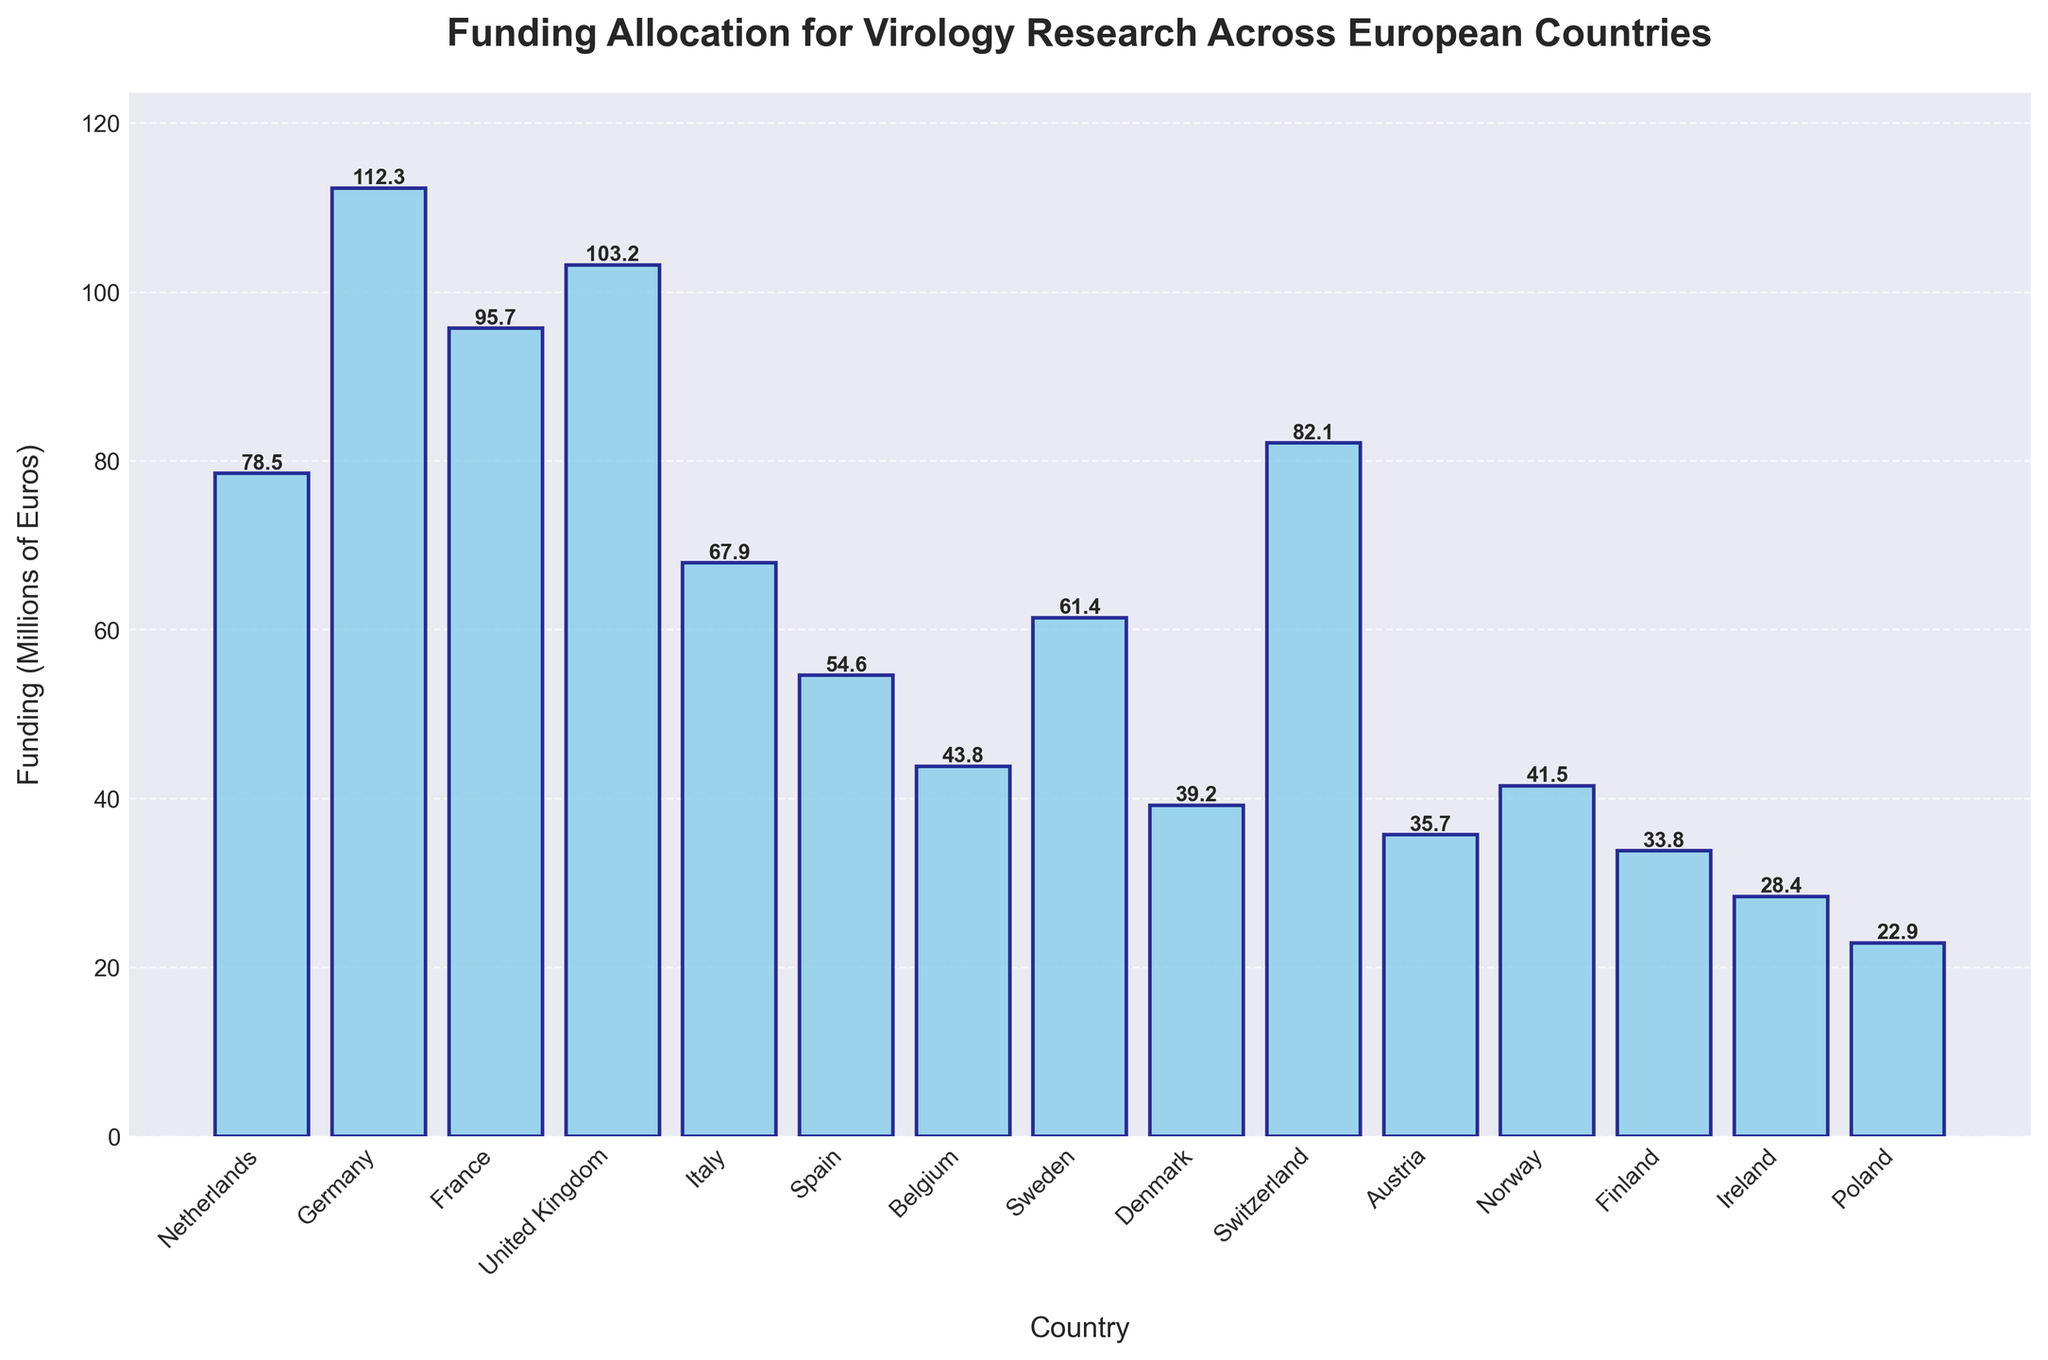Which country receives the most funding? The bar representing Germany has the highest height on the chart, indicating it receives the most funding.
Answer: Germany Which country receives the least funding? The bar representing Poland has the lowest height on the chart, indicating it receives the least funding.
Answer: Poland How much more funding does the United Kingdom receive compared to Italy? The height of the bar for the United Kingdom is 103.2 and for Italy is 67.9. Subtract 67.9 from 103.2 to find the difference.
Answer: 35.3 What is the average funding allocation across all countries? Sum all the funding allocations: 78.5 + 112.3 + 95.7 + 103.2 + 67.9 + 54.6 + 43.8 + 61.4 + 39.2 + 82.1 + 35.7 + 41.5 + 33.8 + 28.4 + 22.9 = 901.0. Divide by the number of countries, which is 15.
Answer: 60.1 Which countries receive more funding than the average? The average funding is 60.1 million euros. The countries above this threshold in bar height are Netherlands, Germany, France, United Kingdom, Italy, Sweden, and Switzerland.
Answer: Netherlands, Germany, France, United Kingdom, Italy, Sweden, Switzerland What is the combined funding for the three countries with the highest allocations? The three highest bars represent Germany (112.3), United Kingdom (103.2), and France (95.7). Sum these amounts: 112.3 + 103.2 + 95.7 = 311.2
Answer: 311.2 Which country shows approximately half the funding of Germany? Germany’s funding is 112.3. Half of this is 112.3 / 2 = 56.15. The closest bar height is Spain at 54.6.
Answer: Spain 